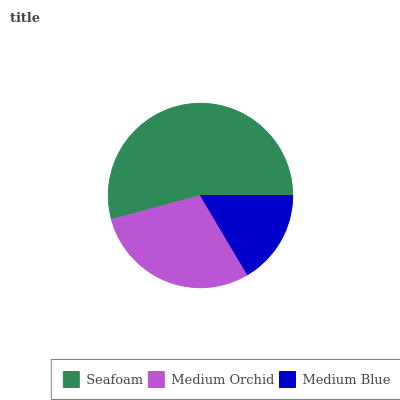Is Medium Blue the minimum?
Answer yes or no. Yes. Is Seafoam the maximum?
Answer yes or no. Yes. Is Medium Orchid the minimum?
Answer yes or no. No. Is Medium Orchid the maximum?
Answer yes or no. No. Is Seafoam greater than Medium Orchid?
Answer yes or no. Yes. Is Medium Orchid less than Seafoam?
Answer yes or no. Yes. Is Medium Orchid greater than Seafoam?
Answer yes or no. No. Is Seafoam less than Medium Orchid?
Answer yes or no. No. Is Medium Orchid the high median?
Answer yes or no. Yes. Is Medium Orchid the low median?
Answer yes or no. Yes. Is Seafoam the high median?
Answer yes or no. No. Is Seafoam the low median?
Answer yes or no. No. 